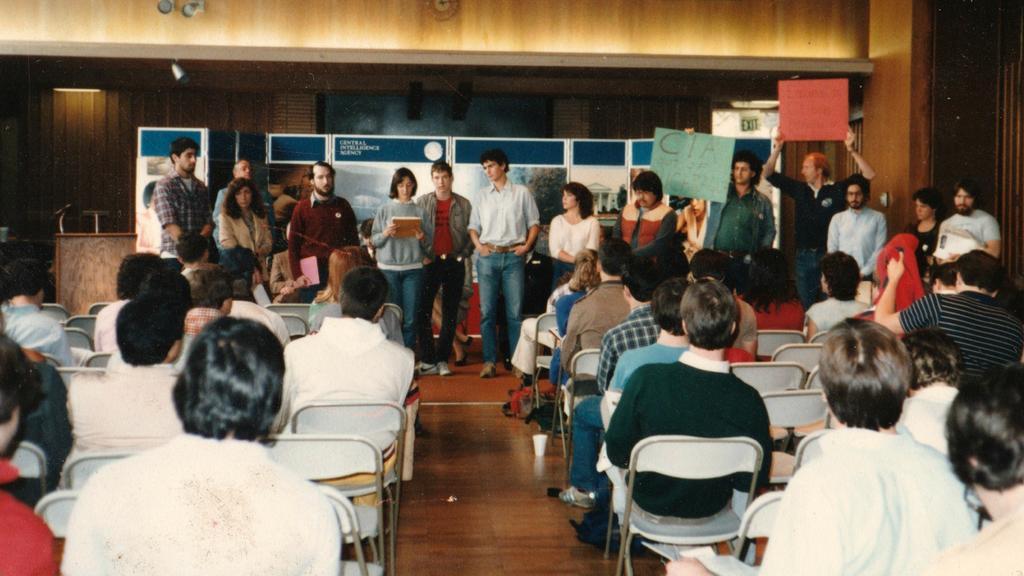Can you describe this image briefly? This picture is taken in a classroom. In the foreground of the picture there are many people seated in chairs. In the background there are many people standing. On the top of the background there is a hoarding and behind the holding there is a board and a wooden wall. Floor is made of wooden. On the top left there is a podium and mic on it. 